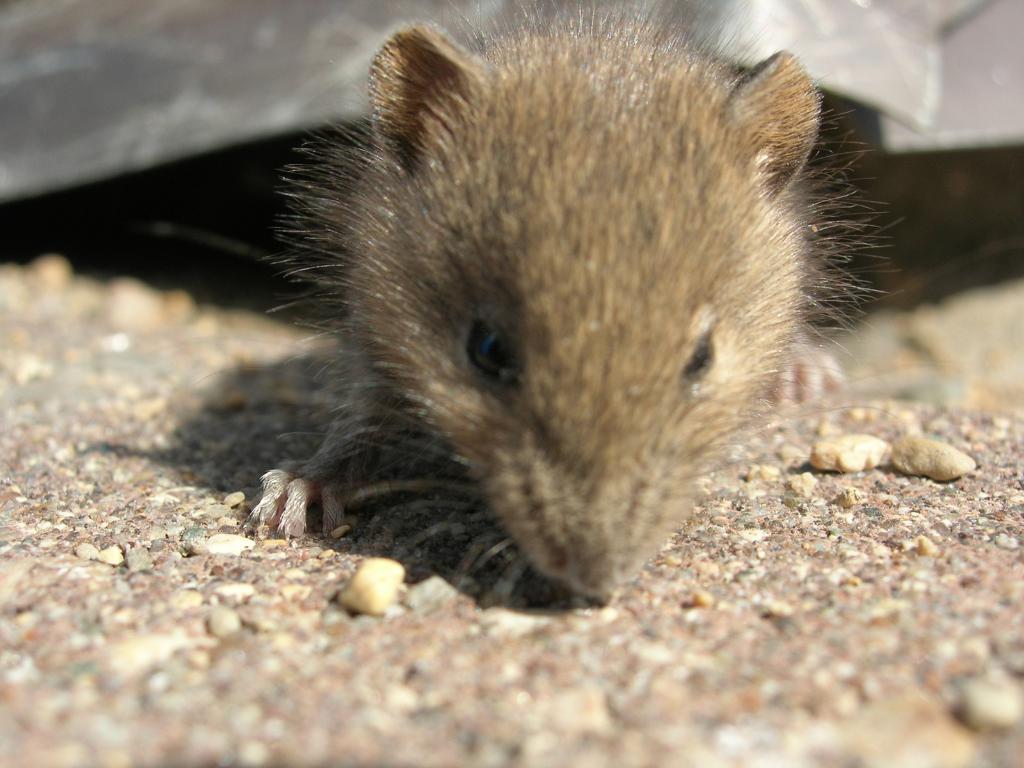Describe this image in one or two sentences. In the image there is a small cute rat. 